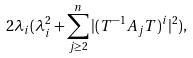Convert formula to latex. <formula><loc_0><loc_0><loc_500><loc_500>2 \lambda _ { i } ( \lambda _ { i } ^ { 2 } + \sum _ { j \geq 2 } ^ { n } | ( T ^ { - 1 } A _ { j } T ) ^ { i } | ^ { 2 } ) ,</formula> 